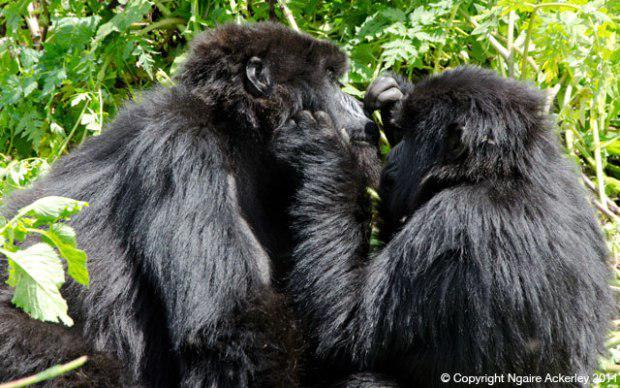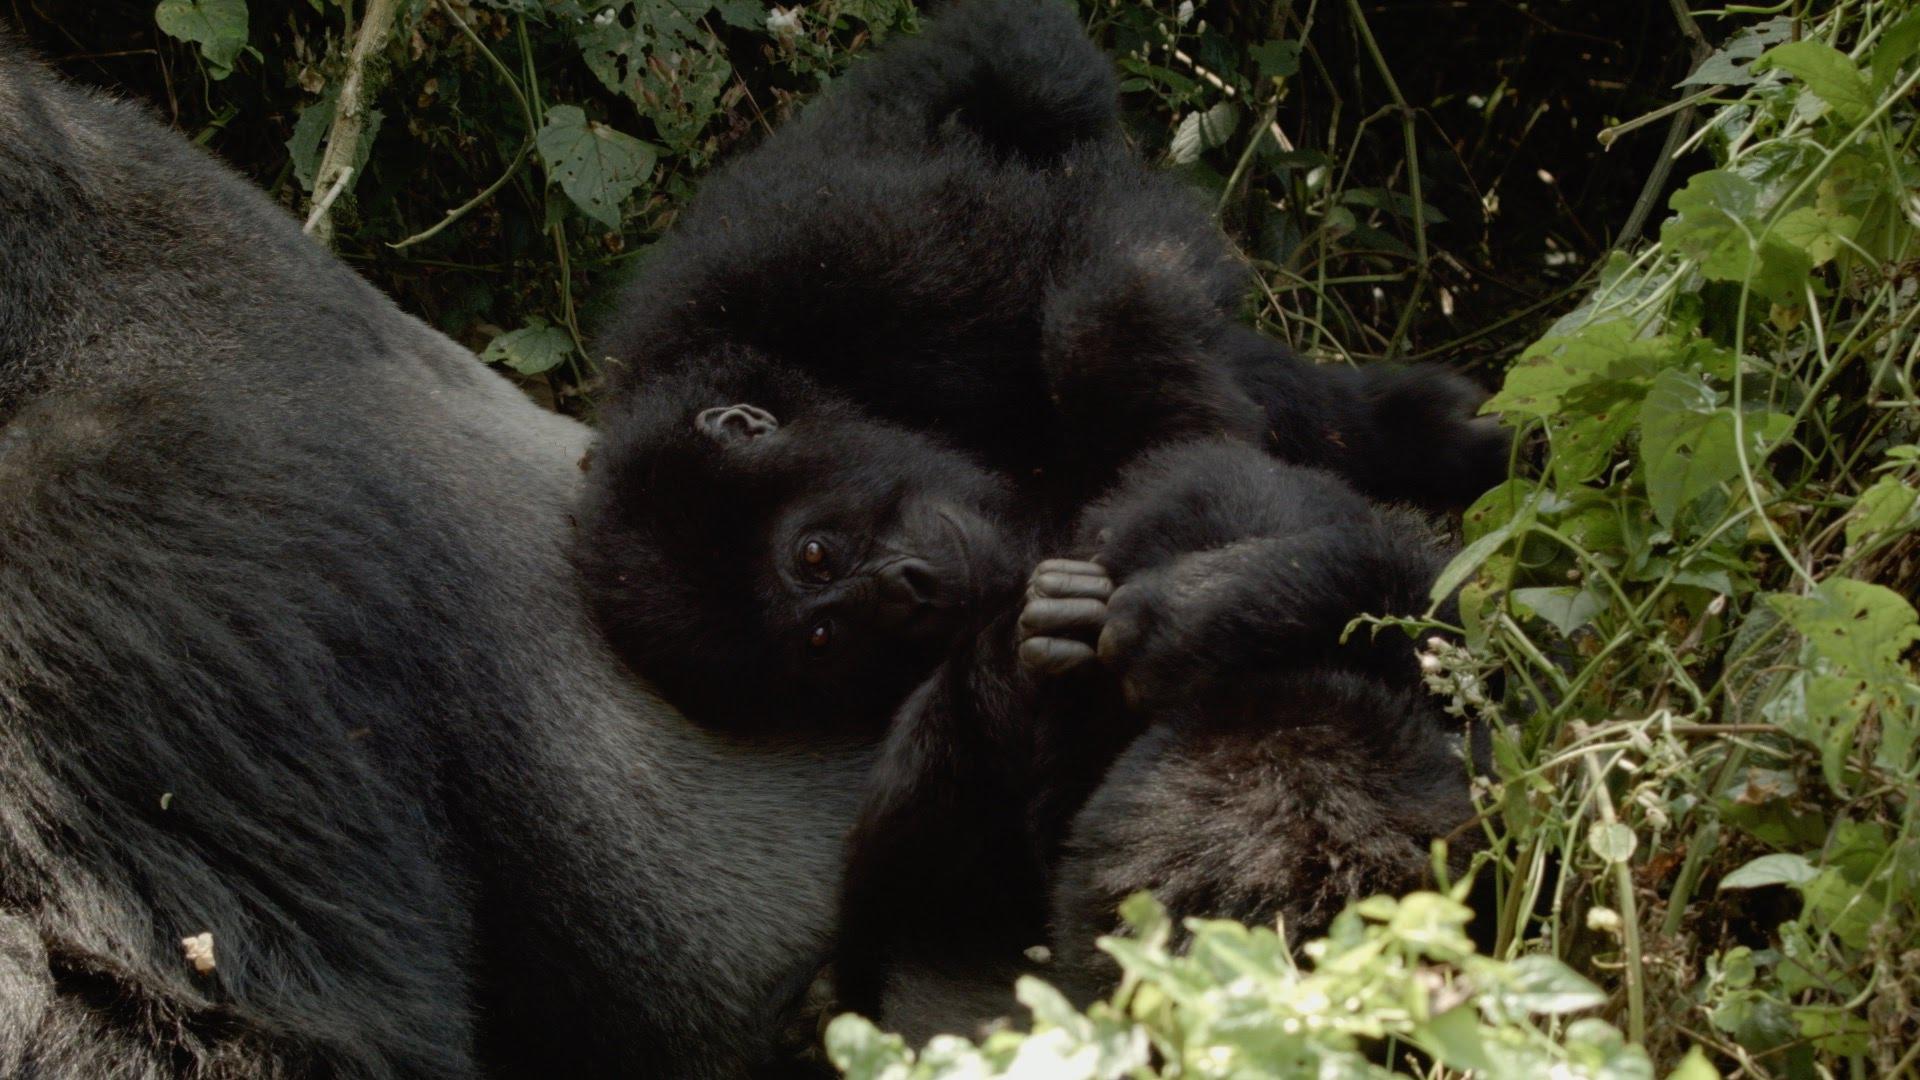The first image is the image on the left, the second image is the image on the right. For the images displayed, is the sentence "One image shows one shaggy-haired gorilla grooming the head of a different shaggy haired gorilla, with the curled fingers of one hand facing the camera." factually correct? Answer yes or no. Yes. The first image is the image on the left, the second image is the image on the right. Examine the images to the left and right. Is the description "One of the images depicts a gorilla grooming from behind it." accurate? Answer yes or no. No. 